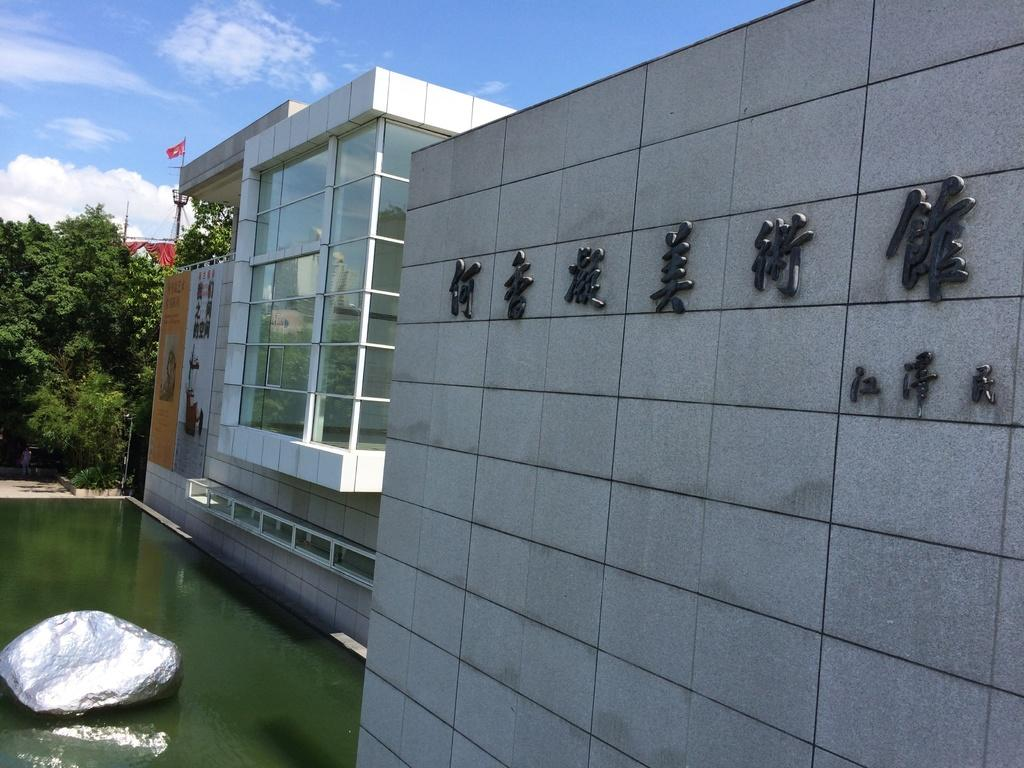What type of structures can be seen in the image? There are buildings in the image. What other natural elements are present in the image? There are trees in the image. What object is supporting the flag? There is a pole in the image that supports the flag. What body of water is visible in the image? There is a pool in the image. What is floating on the surface of the water? There is a rock-like object on the surface of the water. What is visible at the top of the image? The sky is visible at the top of the image. What can be seen in the sky? There are clouds in the sky. How many hands are holding the rock-like object in the image? There are no hands visible in the image, and the rock-like object is floating on the surface of the water. Who is the partner of the person standing next to the pool in the image? There is no person standing next to the pool in the image, and no partner is mentioned or implied. 